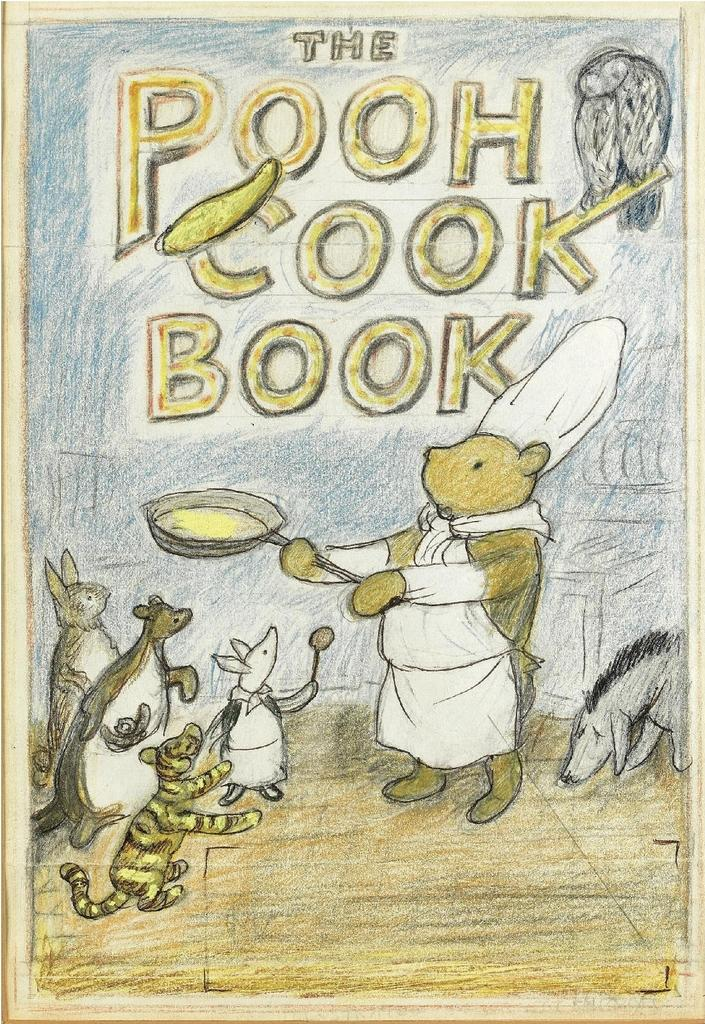What type of drawings can be seen in the image? There are drawings of animals in the image. What else is featured in the image besides the drawings? There is text present in the image. What type of addition problem can be solved using the drawings of animals in the image? There is no addition problem present in the image; it features drawings of animals and text. What type of work is being done in the image? The image does not depict any work being done; it features drawings of animals and text. 